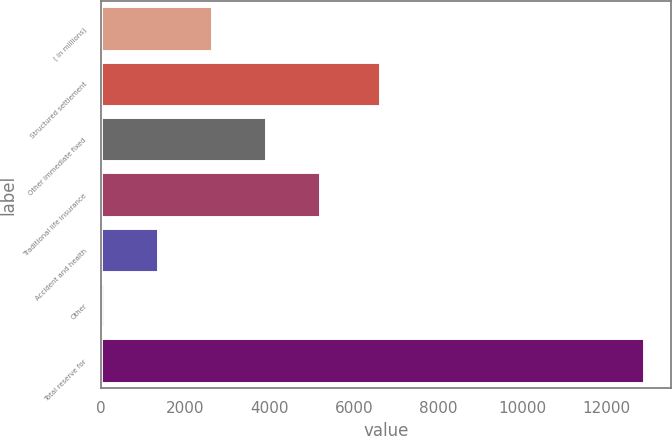Convert chart to OTSL. <chart><loc_0><loc_0><loc_500><loc_500><bar_chart><fcel>( in millions)<fcel>Structured settlement<fcel>Other immediate fixed<fcel>Traditional life insurance<fcel>Accident and health<fcel>Other<fcel>Total reserve for<nl><fcel>2636.2<fcel>6628<fcel>3917.4<fcel>5198.6<fcel>1355<fcel>69<fcel>12881<nl></chart> 